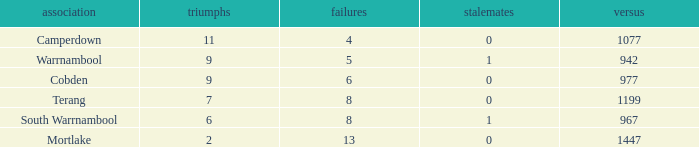How many draws did Mortlake have when the losses were more than 5? 1.0. 